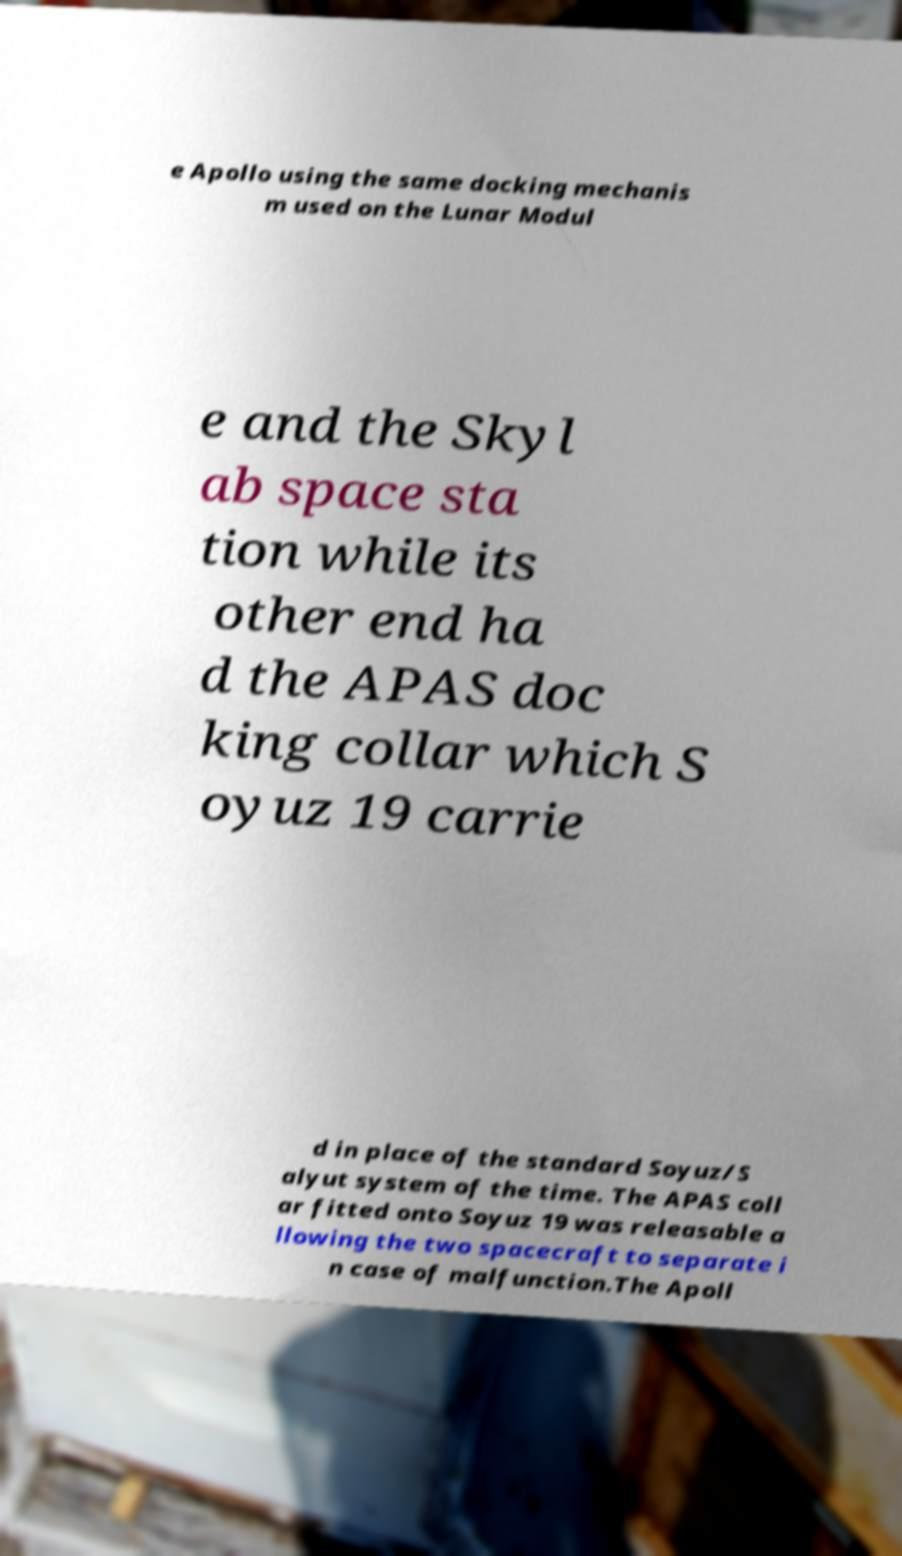Can you read and provide the text displayed in the image?This photo seems to have some interesting text. Can you extract and type it out for me? e Apollo using the same docking mechanis m used on the Lunar Modul e and the Skyl ab space sta tion while its other end ha d the APAS doc king collar which S oyuz 19 carrie d in place of the standard Soyuz/S alyut system of the time. The APAS coll ar fitted onto Soyuz 19 was releasable a llowing the two spacecraft to separate i n case of malfunction.The Apoll 